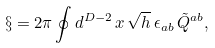<formula> <loc_0><loc_0><loc_500><loc_500>\S = 2 \pi \oint d ^ { D - 2 } \, x \, \sqrt { h } \, \epsilon _ { a b } \, \tilde { Q } ^ { a b } ,</formula> 